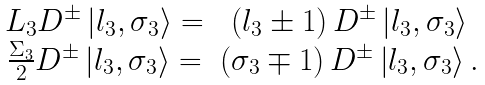<formula> <loc_0><loc_0><loc_500><loc_500>\begin{array} { c c } L _ { 3 } D ^ { \pm } \left | l _ { 3 } , \sigma _ { 3 } \right \rangle = & \left ( l _ { 3 } \pm 1 \right ) D ^ { \pm } \left | l _ { 3 } , \sigma _ { 3 } \right \rangle \\ \frac { \Sigma _ { 3 } } { 2 } D ^ { \pm } \left | l _ { 3 } , \sigma _ { 3 } \right \rangle = & \left ( \sigma _ { 3 } \mp 1 \right ) D ^ { \pm } \left | l _ { 3 } , \sigma _ { 3 } \right \rangle . \end{array}</formula> 